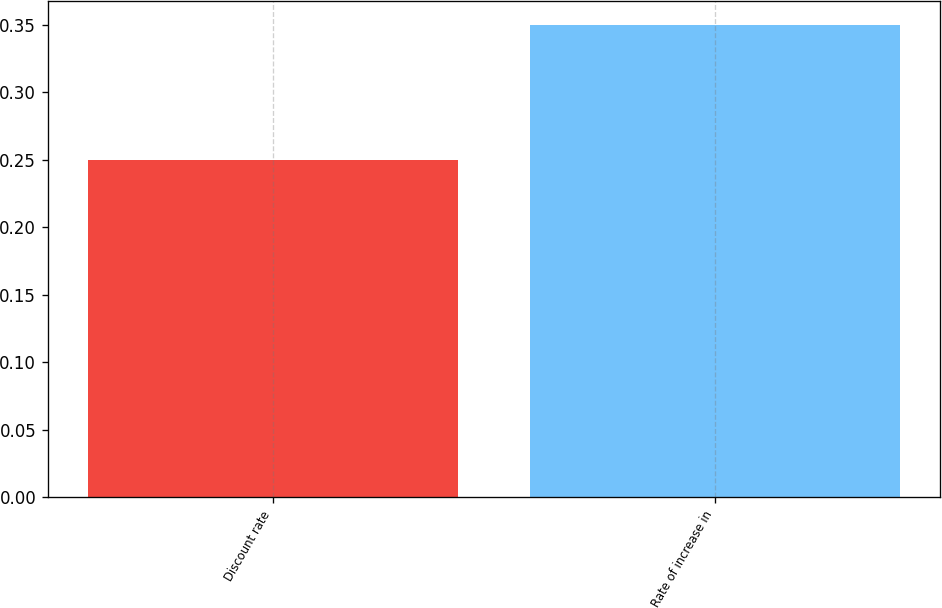Convert chart to OTSL. <chart><loc_0><loc_0><loc_500><loc_500><bar_chart><fcel>Discount rate<fcel>Rate of increase in<nl><fcel>0.25<fcel>0.35<nl></chart> 